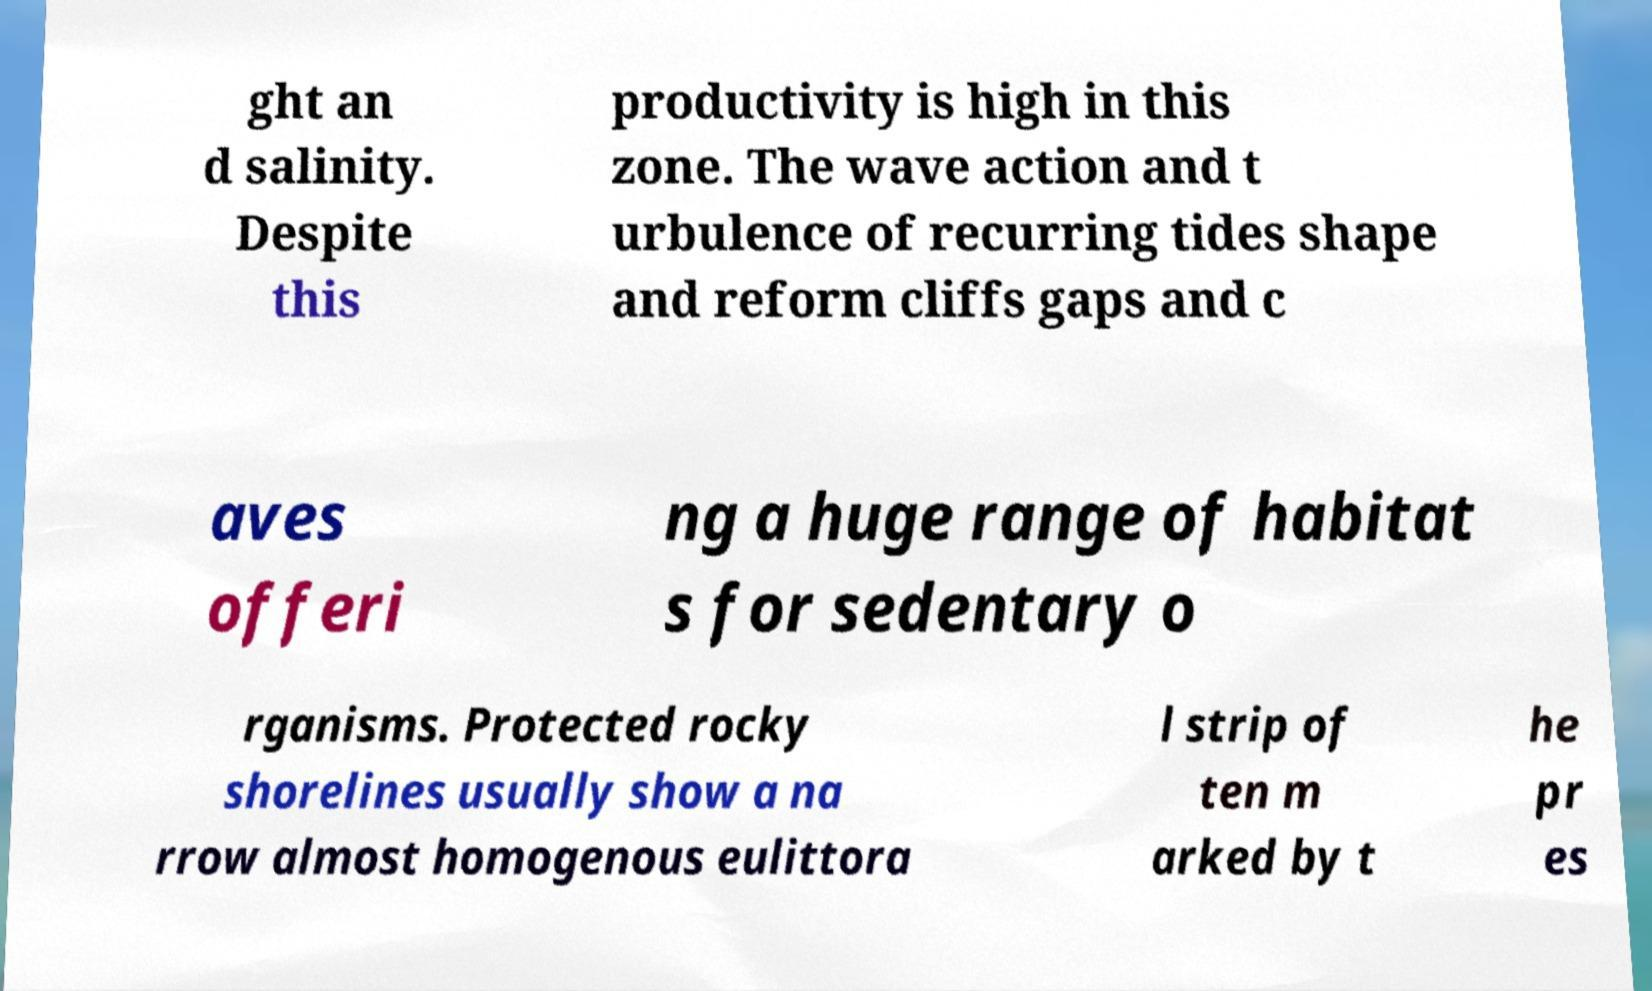Please read and relay the text visible in this image. What does it say? ght an d salinity. Despite this productivity is high in this zone. The wave action and t urbulence of recurring tides shape and reform cliffs gaps and c aves offeri ng a huge range of habitat s for sedentary o rganisms. Protected rocky shorelines usually show a na rrow almost homogenous eulittora l strip of ten m arked by t he pr es 